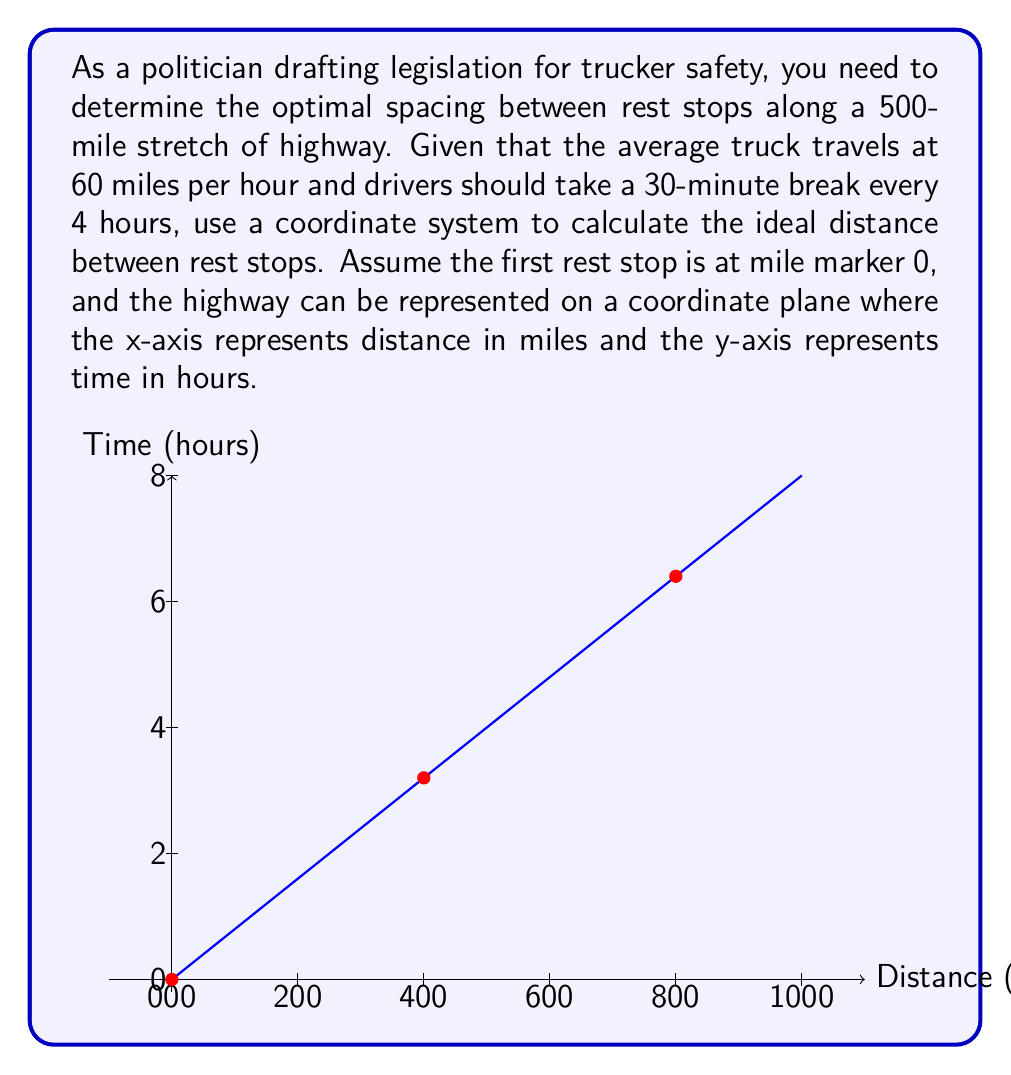What is the answer to this math problem? To solve this problem, we'll follow these steps:

1) First, let's calculate how far a truck can travel in 4 hours:
   $$\text{Distance} = \text{Speed} \times \text{Time}$$
   $$\text{Distance} = 60 \text{ miles/hour} \times 4 \text{ hours} = 240 \text{ miles}$$

2) This means that rest stops should ideally be placed every 240 miles.

3) To represent this on our coordinate system:
   - The x-axis represents distance in miles
   - The y-axis represents time in hours
   - The line $y = \frac{x}{60}$ represents the truck's journey (since it travels 60 miles per hour)

4) We can plot points where rest stops should be located:
   - (0, 0) - Starting point
   - (240, 4) - First rest stop
   - (480, 8) - Second rest stop

5) The 500-mile stretch can accommodate two full intervals of 240 miles, with 20 miles remaining.

6) To calculate the number of rest stops needed:
   $$\text{Number of rest stops} = \left\lfloor\frac{500}{240}\right\rfloor + 1 = 2 + 1 = 3$$
   (We add 1 because we count the starting point as a rest stop)

7) The optimal spacing between rest stops is therefore 240 miles.
Answer: The optimal spacing between rest stops along the 500-mile highway is 240 miles, with a total of 3 rest stops (including the starting point) located at mile markers 0, 240, and 480. 